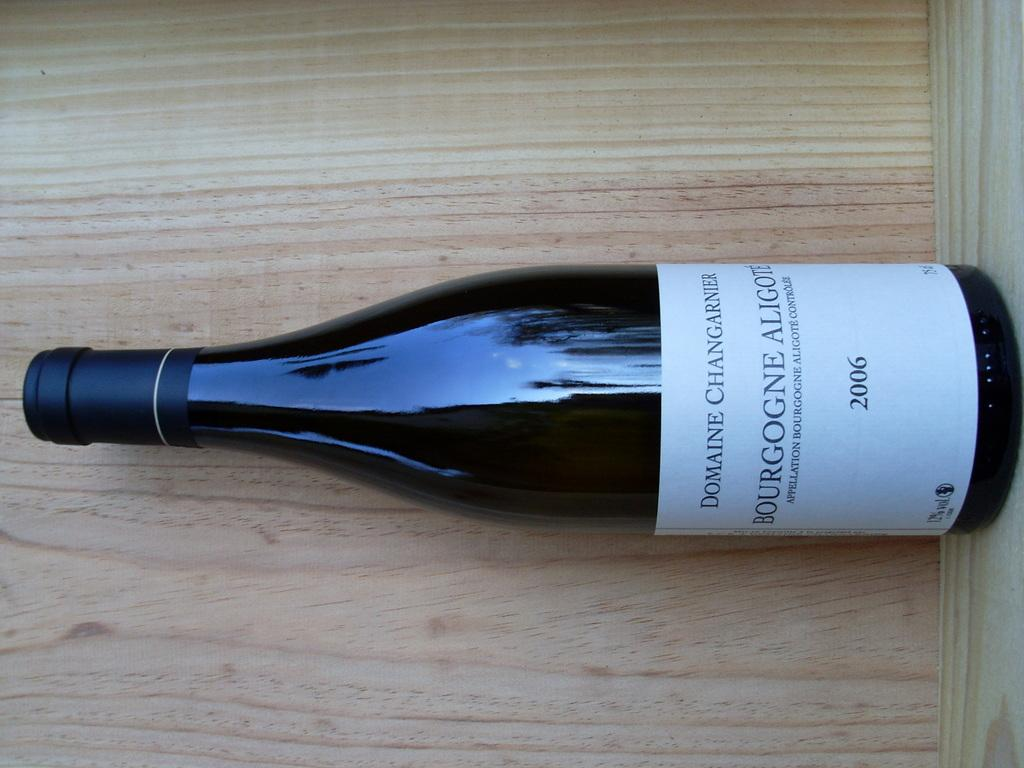<image>
Give a short and clear explanation of the subsequent image. A bottle of a 2006 vintage wine produced by Domaine Changarnier rests on a wooden shelf. 